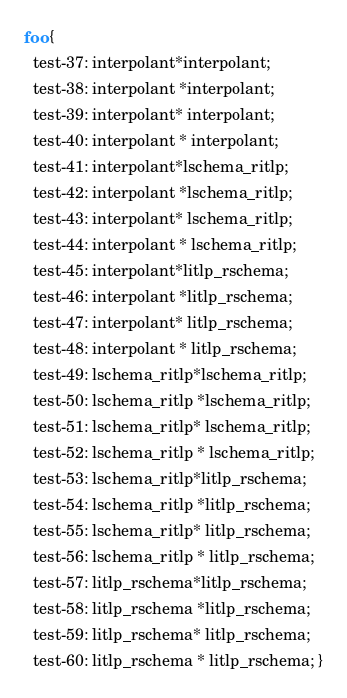<code> <loc_0><loc_0><loc_500><loc_500><_CSS_>foo {
  test-37: interpolant*interpolant;
  test-38: interpolant *interpolant;
  test-39: interpolant* interpolant;
  test-40: interpolant * interpolant;
  test-41: interpolant*lschema_ritlp;
  test-42: interpolant *lschema_ritlp;
  test-43: interpolant* lschema_ritlp;
  test-44: interpolant * lschema_ritlp;
  test-45: interpolant*litlp_rschema;
  test-46: interpolant *litlp_rschema;
  test-47: interpolant* litlp_rschema;
  test-48: interpolant * litlp_rschema;
  test-49: lschema_ritlp*lschema_ritlp;
  test-50: lschema_ritlp *lschema_ritlp;
  test-51: lschema_ritlp* lschema_ritlp;
  test-52: lschema_ritlp * lschema_ritlp;
  test-53: lschema_ritlp*litlp_rschema;
  test-54: lschema_ritlp *litlp_rschema;
  test-55: lschema_ritlp* litlp_rschema;
  test-56: lschema_ritlp * litlp_rschema;
  test-57: litlp_rschema*litlp_rschema;
  test-58: litlp_rschema *litlp_rschema;
  test-59: litlp_rschema* litlp_rschema;
  test-60: litlp_rschema * litlp_rschema; }
</code> 